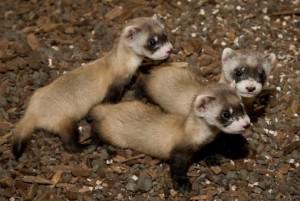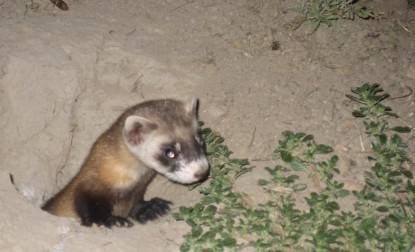The first image is the image on the left, the second image is the image on the right. Analyze the images presented: Is the assertion "The left and right image contains the same number of small rodents." valid? Answer yes or no. No. The first image is the image on the left, the second image is the image on the right. Examine the images to the left and right. Is the description "There is at least one black footed ferret looking to the right side of the image." accurate? Answer yes or no. Yes. The first image is the image on the left, the second image is the image on the right. For the images displayed, is the sentence "All of the ferrets are visible as a full body shot." factually correct? Answer yes or no. No. The first image is the image on the left, the second image is the image on the right. Analyze the images presented: Is the assertion "There is at least one ferret in a hole." valid? Answer yes or no. Yes. 